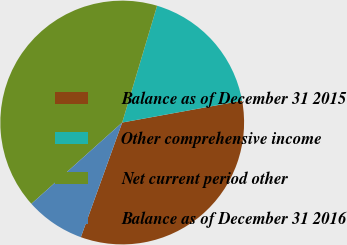<chart> <loc_0><loc_0><loc_500><loc_500><pie_chart><fcel>Balance as of December 31 2015<fcel>Other comprehensive income<fcel>Net current period other<fcel>Balance as of December 31 2016<nl><fcel>33.38%<fcel>17.51%<fcel>41.24%<fcel>7.87%<nl></chart> 